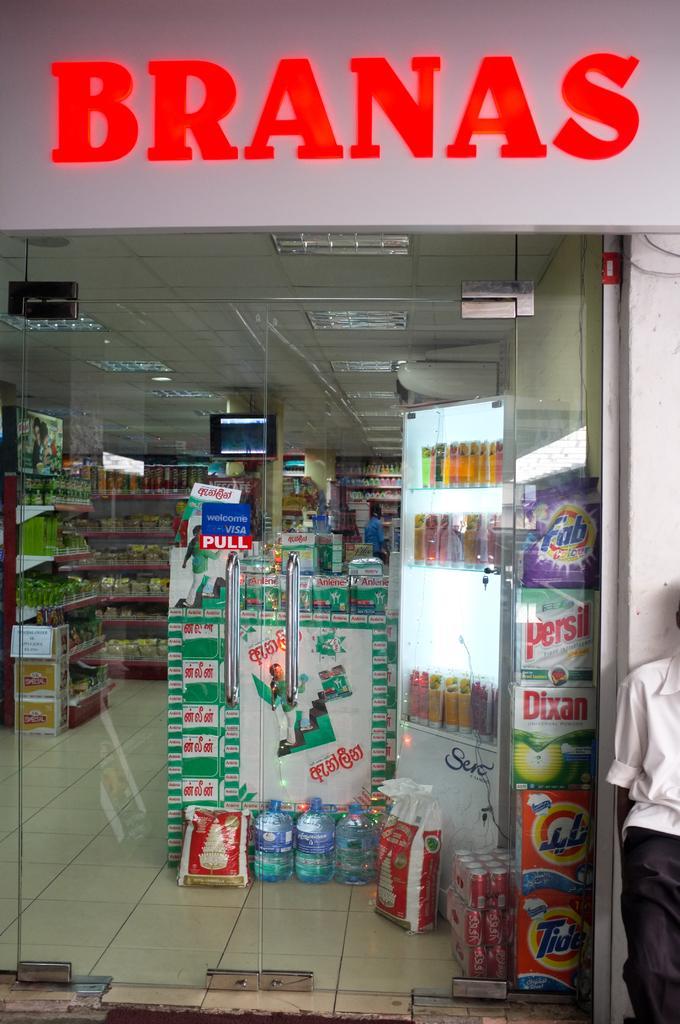In one or two sentences, can you explain what this image depicts? In this picture I can observe a store. On the top of the picture I can observe some text. There is a glass door in middle of the picture. 